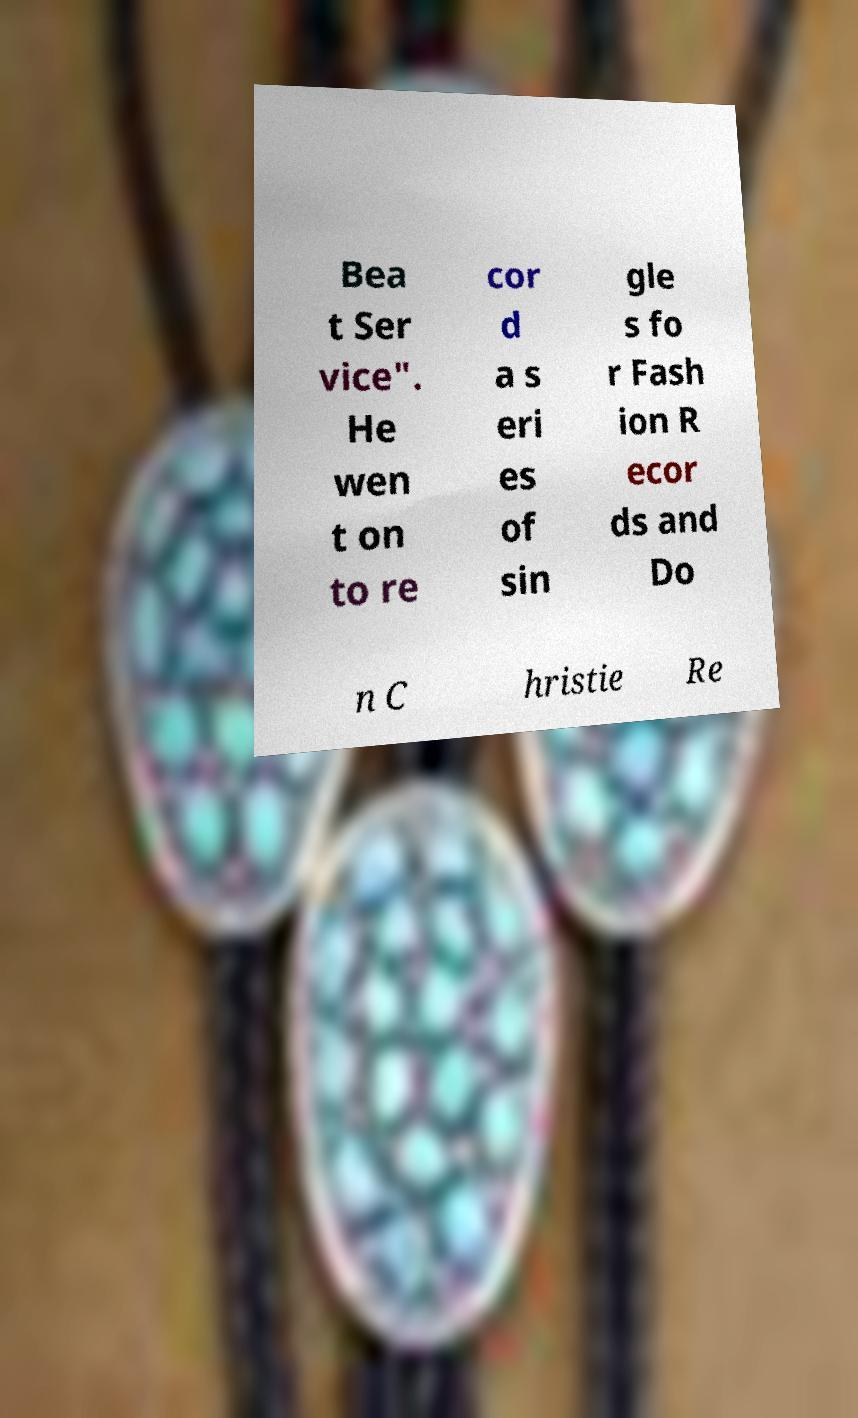Can you read and provide the text displayed in the image?This photo seems to have some interesting text. Can you extract and type it out for me? Bea t Ser vice". He wen t on to re cor d a s eri es of sin gle s fo r Fash ion R ecor ds and Do n C hristie Re 